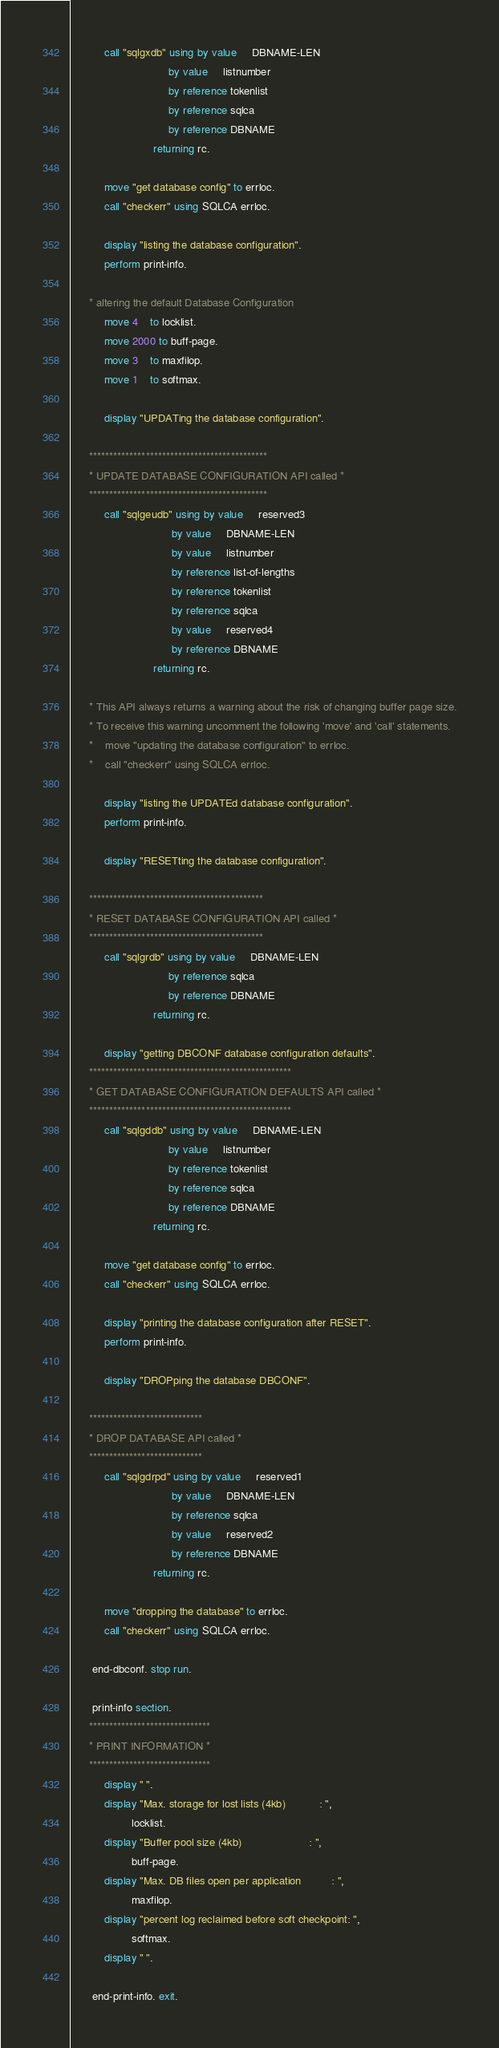Convert code to text. <code><loc_0><loc_0><loc_500><loc_500><_COBOL_>           call "sqlgxdb" using by value     DBNAME-LEN
                                by value     listnumber
                                by reference tokenlist
                                by reference sqlca
                                by reference DBNAME
                           returning rc.

           move "get database config" to errloc.
           call "checkerr" using SQLCA errloc.

           display "listing the database configuration".
           perform print-info.

      * altering the default Database Configuration
           move 4    to locklist.
           move 2000 to buff-page.
           move 3    to maxfilop.
           move 1    to softmax.

           display "UPDATing the database configuration".
 
      ********************************************
      * UPDATE DATABASE CONFIGURATION API called *
      ********************************************
           call "sqlgeudb" using by value     reserved3
                                 by value     DBNAME-LEN
                                 by value     listnumber
                                 by reference list-of-lengths
                                 by reference tokenlist
                                 by reference sqlca
                                 by value     reserved4
                                 by reference DBNAME
                           returning rc.

      * This API always returns a warning about the risk of changing buffer page size.
      * To receive this warning uncomment the following 'move' and 'call' statements.
      *    move "updating the database configuration" to errloc.
      *    call "checkerr" using SQLCA errloc.

           display "listing the UPDATEd database configuration".
           perform print-info.

           display "RESETting the database configuration".
 
      *******************************************
      * RESET DATABASE CONFIGURATION API called *
      *******************************************
           call "sqlgrdb" using by value     DBNAME-LEN
                                by reference sqlca    
                                by reference DBNAME
                           returning rc.

           display "getting DBCONF database configuration defaults".
      **************************************************
      * GET DATABASE CONFIGURATION DEFAULTS API called *
      **************************************************
           call "sqlgddb" using by value     DBNAME-LEN
                                by value     listnumber
                                by reference tokenlist
                                by reference sqlca
                                by reference DBNAME
                           returning rc.

           move "get database config" to errloc.
           call "checkerr" using SQLCA errloc.

           display "printing the database configuration after RESET".
           perform print-info.

           display "DROPping the database DBCONF".
 
      ****************************
      * DROP DATABASE API called *
      ****************************
           call "sqlgdrpd" using by value     reserved1
                                 by value     DBNAME-LEN
                                 by reference sqlca
                                 by value     reserved2
                                 by reference DBNAME
                           returning rc.

           move "dropping the database" to errloc.
           call "checkerr" using SQLCA errloc.

       end-dbconf. stop run.

       print-info section.
      ******************************
      * PRINT INFORMATION *
      ******************************
           display " ".
           display "Max. storage for lost lists (4kb)           : ",
                    locklist.
           display "Buffer pool size (4kb)                      : ",
                    buff-page.
           display "Max. DB files open per application          : ",
                    maxfilop.
           display "percent log reclaimed before soft checkpoint: ",
                    softmax.
           display " ".

       end-print-info. exit.


</code> 